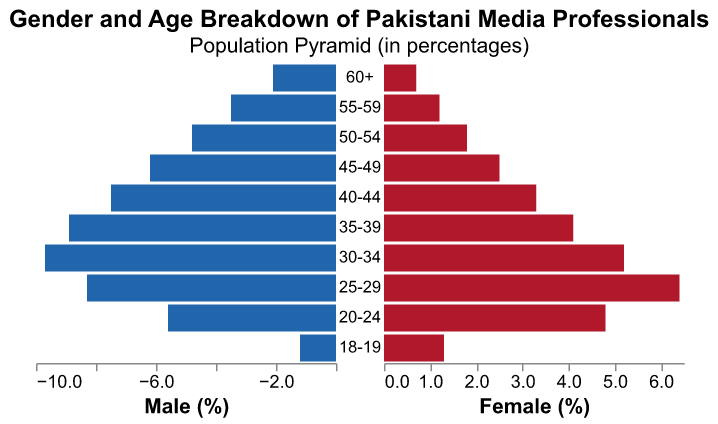What is the age group with the highest percentage of female media professionals? The age group with the highest percentage of female media professionals can be found by looking at the figure and identifying the tallest bar on the Female side (right). The data shows that the age group 25-29 has the highest percentage of female media professionals at 6.4%.
Answer: 25-29 Which gender has more professionals in the 40-44 age group? To determine which gender has more professionals in the 40-44 age group, compare Male and Female percentages for this age group. The figure shows that 7.5% are male and 3.3% are female, indicating that more professionals are male in this age group.
Answer: Male At what age group do female media professionals outnumber their male counterparts? By visually comparing the lengths of the bars on both sides of the figure, we find that the age group 18-19 has a higher percentage of female professionals (1.3%) compared to male professionals (1.2%).
Answer: 18-19 How does the percentage of male media professionals in the 30-34 age group compare to the 40-44 age group? From the figure, we observe that the percentage of male media professionals in the 30-34 age group is 9.7% whereas, in the 40-44 age group, it is 7.5%. Therefore, the percentage of male media professionals is higher in the 30-34 age group.
Answer: Higher What is the total percentage of media professionals in the 50-54 age group? To find the total percentage of media professionals in the 50-54 age group, sum the Male and Female percentages for this group: 4.8% (Male) + 1.8% (Female) = 6.6%.
Answer: 6.6% Is the percentage of female media professionals consistently increasing or decreasing from the 18-19 age group to the 60+ age group? By inspecting the Female figures across the age groups in the figure, we see that while there are fluctuations in different age groups, there is a general increase up to the 25-29 age group, followed by a gradual decline until the 60+ age group.
Answer: Decreasing from peak Which age group shows the most significant gender disparity? The most significant gender disparity can be found by looking for the age group with the largest difference between Male and Female percentages. The figure shows that the 30-34 age group has a disparity of 9.7% (Male) - 5.2% (Female) = 4.5%.
Answer: 30-34 What is the combined percentage of media professionals below 30 years? To find the combined percentage of media professionals below 30 years, sum the Male and Female percentages for the 18-19, 20-24, and 25-29 age groups: (1.2% + 1.3%) + (5.6% + 4.8%) + (8.3% + 6.4%) = 27.6%.
Answer: 27.6% In which age group do we find the least percentage of media professionals? From the figure, the least percentage of media professionals can be found by identifying the smallest combined percentage of Male and Female in an age group. The 60+ age group has the least with a combined percentage of 2.1% (Male) + 0.7% (Female) = 2.8%.
Answer: 60+ Does the 55-59 age group have a higher percentage of male or female media professionals compared to the 45-49 age group? Compare the percentages of Male and Female in the 55-59 age group to the percentages in the 45-49 age group from the figure. The 55-59 group has 3.5% males and 1.2% females, whereas the 45-49 group has 6.2% males and 2.5% females. Thus, the 45-49 age group has a higher percentage of both male and female media professionals.
Answer: 45-49 